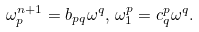Convert formula to latex. <formula><loc_0><loc_0><loc_500><loc_500>\omega _ { p } ^ { n + 1 } = b _ { p q } \omega ^ { q } , \, \omega _ { 1 } ^ { p } = c _ { q } ^ { p } \omega ^ { q } .</formula> 